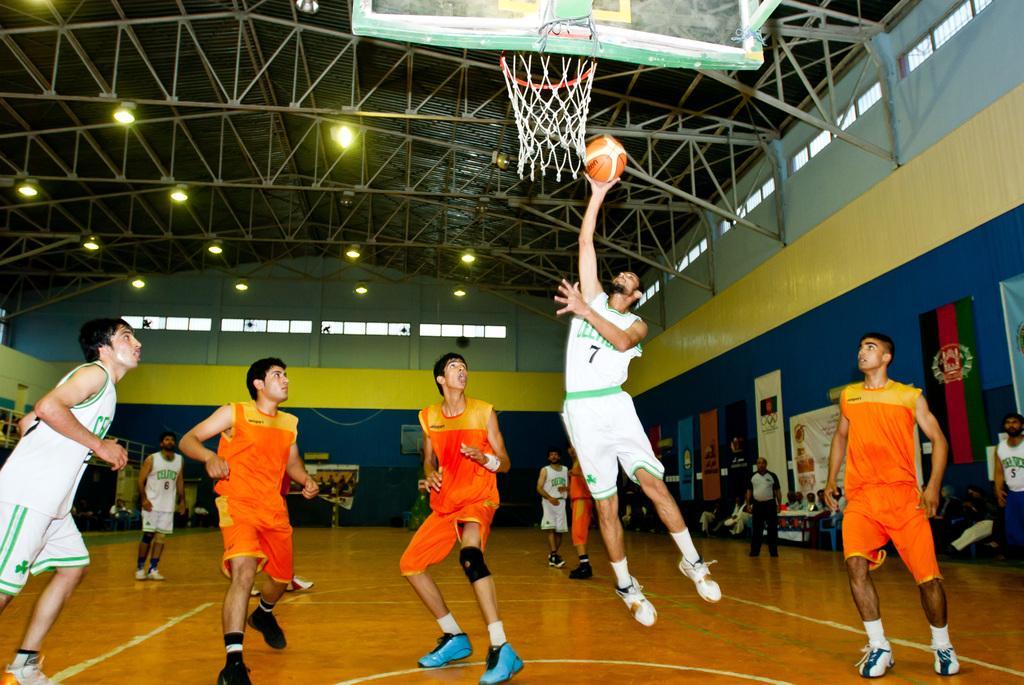Please provide a concise description of this image. In the image there are few people standing on the football court. There is a person holding a ball in the hand and he is in the air. At the top of the image there is a board with a basket. In the background on the right side there are a few people sitting. Behind them there is a wall with flags and also there are posters. And also there are some other things in the background. At the top of the image there is ceiling with lights and also there are rods. And on the walls there are pillars and glass windows. 